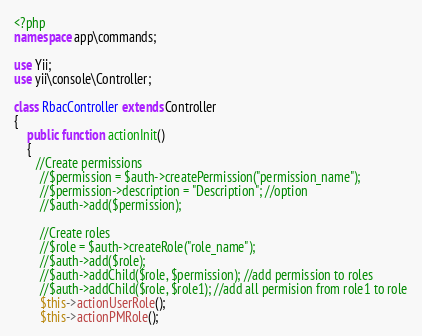<code> <loc_0><loc_0><loc_500><loc_500><_PHP_><?php
namespace app\commands;

use Yii;
use yii\console\Controller;

class RbacController extends Controller
{
    public function actionInit()
    {
       //Create permissions
        //$permission = $auth->createPermission("permission_name");
        //$permission->description = "Description"; //option
        //$auth->add($permission);

        //Create roles
        //$role = $auth->createRole("role_name");
        //$auth->add($role);
        //$auth->addChild($role, $permission); //add permission to roles
        //$auth->addChild($role, $role1); //add all permision from role1 to role
        $this->actionUserRole();
        $this->actionPMRole();</code> 